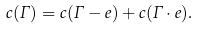Convert formula to latex. <formula><loc_0><loc_0><loc_500><loc_500>c ( \Gamma ) = c ( \Gamma - e ) + c ( \Gamma \cdot e ) .</formula> 